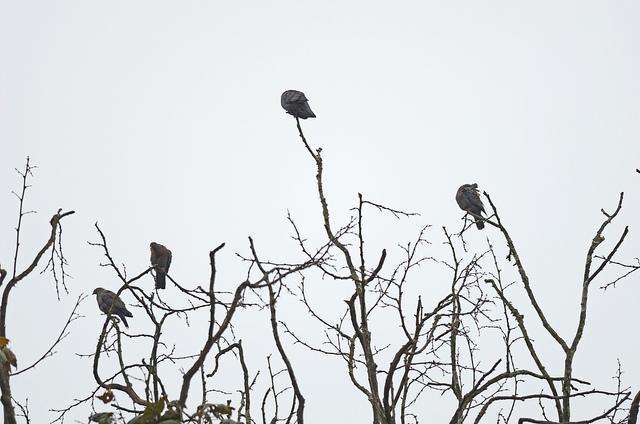How many birds are on the tree limbs?
Give a very brief answer. 4. How many birds are in the picture?
Give a very brief answer. 4. How many birds are in the trees?
Give a very brief answer. 4. How many birds are visible?
Give a very brief answer. 4. 